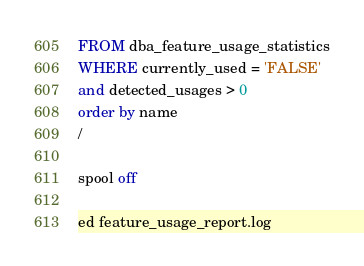<code> <loc_0><loc_0><loc_500><loc_500><_SQL_>FROM dba_feature_usage_statistics
WHERE currently_used = 'FALSE'
and detected_usages > 0
order by name
/

spool off

ed feature_usage_report.log
</code> 